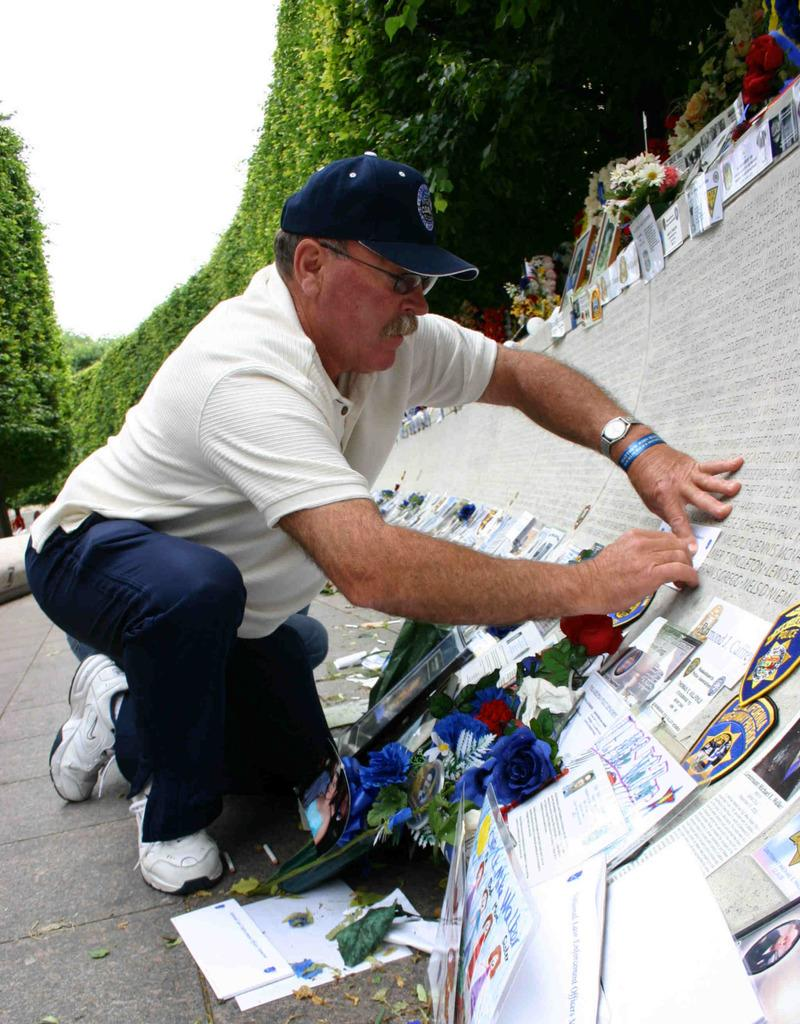What is the person in the image doing? The person is sticking cards on a wall. What accessories is the person wearing? The person is wearing a cap, glasses, and a watch. What can be seen in front of the person? There are flowers in front of the person. What is visible in the background of the image? There are trees in the background of the image. What language is the person speaking in the image? The image does not provide any information about the language the person is speaking. What effect does the person's presence have on the fang of a nearby animal? There is no mention of any nearby animals or fangs in the image. 